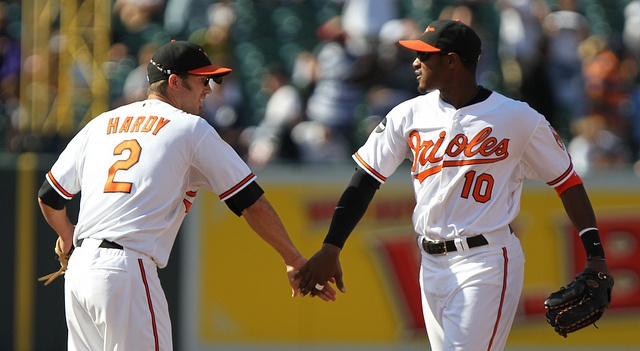Describe the objects in this image and their specific colors. I can see people in black, darkgray, and white tones, people in black, white, darkgray, and maroon tones, people in black, darkgray, gray, and lightgray tones, and baseball glove in black, maroon, olive, and gray tones in this image. 